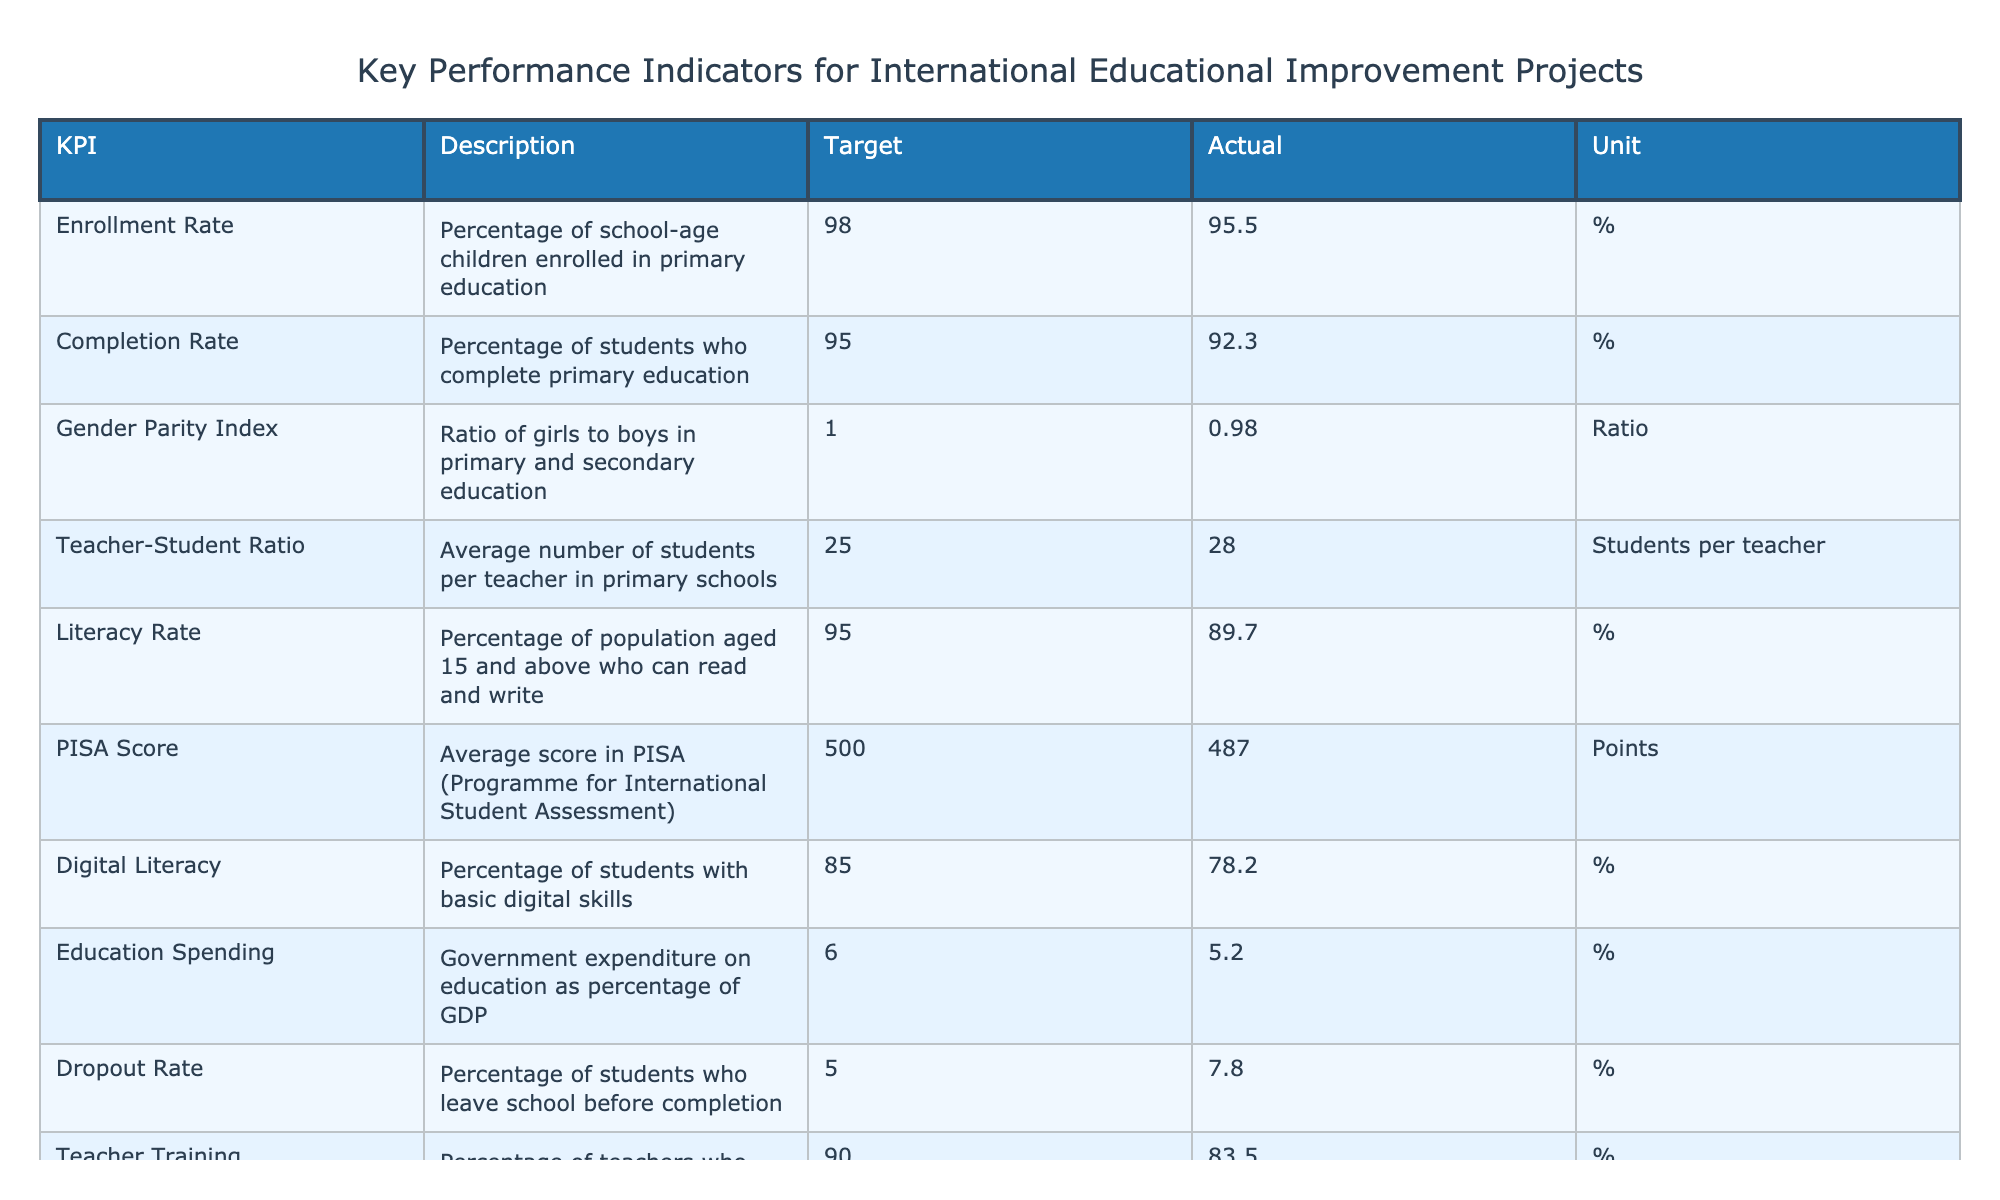What is the target enrollment rate? The target enrollment rate is specified in the 'Target' column for the 'Enrollment Rate' row. The value is 98.
Answer: 98 What is the actual completion rate achieved? The actual completion rate achieved is given in the 'Actual' column for the 'Completion Rate' row. The value is 92.3.
Answer: 92.3 Is the gender parity index at or above the target? The target for the gender parity index is 1.00, but the actual value is 0.98, which is below the target. Therefore, it is not at or above the target.
Answer: No What is the difference between the target literacy rate and the actual literacy rate? The target literacy rate is 95 and the actual literacy rate is 89.7. The difference is calculated as 95 - 89.7, which equals 5.3.
Answer: 5.3 Is the teacher-student ratio higher or lower than the target? The target teacher-student ratio is 25, while the actual ratio is 28, indicating that the actual ratio is higher than the target.
Answer: Higher What is the average actual value for the KPIs provided? To find the average, sum all the actual values: 95.5 + 92.3 + 0.98 + 28 + 89.7 + 487 + 78.2 + 5.2 + 7.8 + 83.5 = 482.5. There are 10 values, so the average is 482.5 / 10 = 48.25.
Answer: 48.25 What percentage of students have basic digital skills compared to the target? The target for digital literacy is 85%, and the actual percentage is 78.2%. To find the difference, subtract the actual from the target: 85 - 78.2 = 6.8%. This shows a shortfall.
Answer: 6.8% Is the dropout rate above the target? The target dropout rate is 5%, and the actual rate is 7.8%, which is higher than the target.
Answer: Yes What percentage of teachers met the training target? The target for teacher training is 90%, while the actual is 83.5%. To find the percentage of teachers who met the training target, check if 83.5% is equal to or above the target. Since 83.5% is below 90%, it means the target was not met.
Answer: No What is the ratio of the teacher-student ratio to the target? The target teacher-student ratio is 25, and the actual is 28. To find the ratio, divide the actual by the target: 28 / 25 = 1.12, indicating that the actual ratio exceeds the target by 12%.
Answer: 1.12 